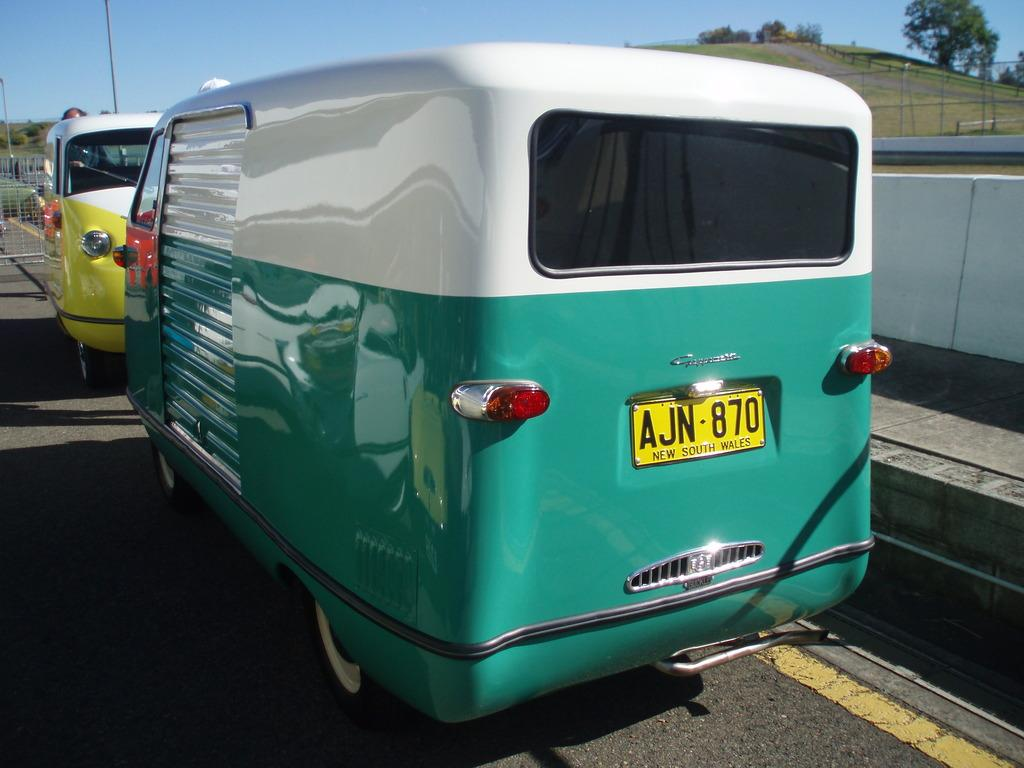<image>
Describe the image concisely. A New South Wales license plate is attached to a boxy blue and white van. 